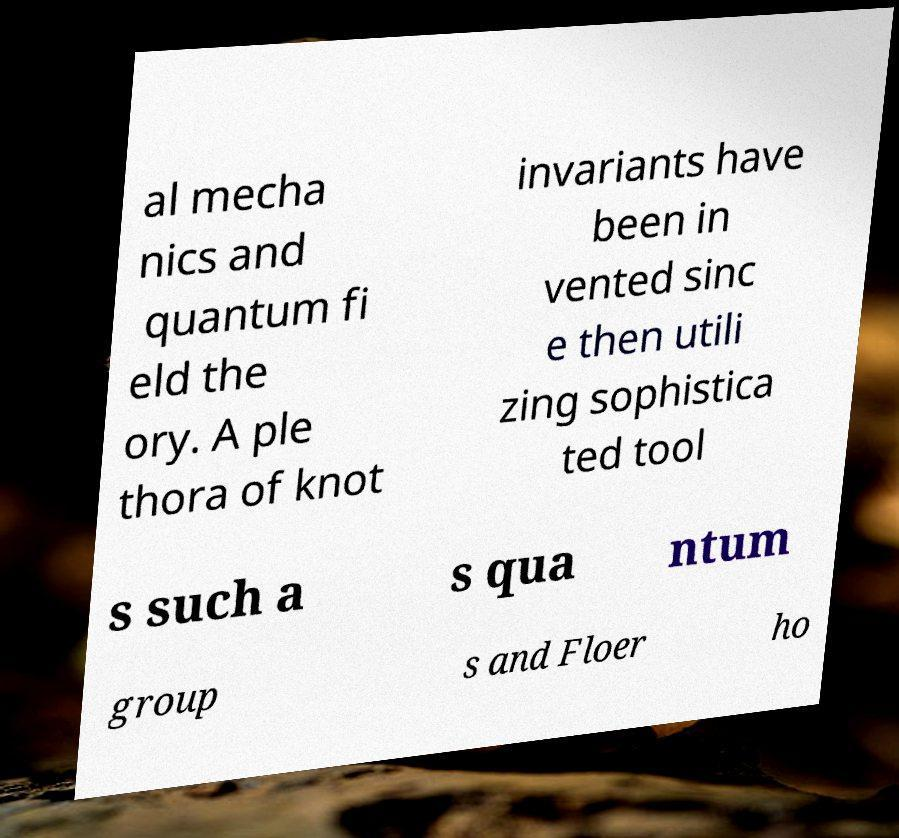I need the written content from this picture converted into text. Can you do that? al mecha nics and quantum fi eld the ory. A ple thora of knot invariants have been in vented sinc e then utili zing sophistica ted tool s such a s qua ntum group s and Floer ho 